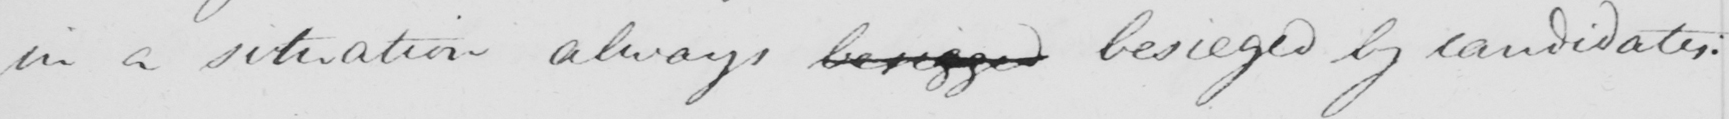What does this handwritten line say? in a situation always besigged besieged by candidates : 